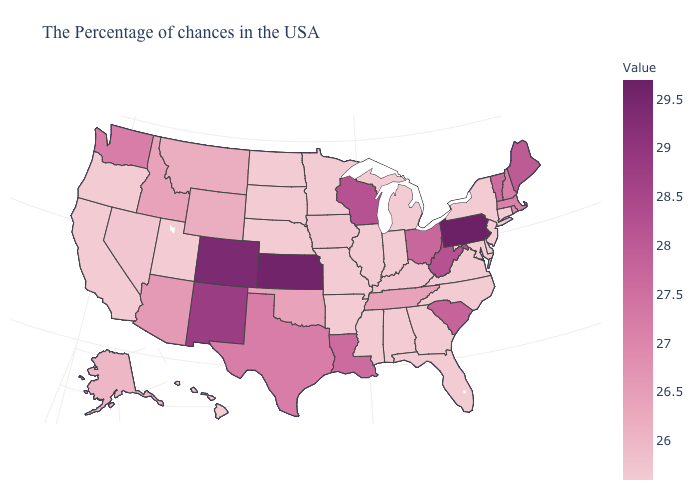Which states hav the highest value in the West?
Concise answer only. Colorado. Does Georgia have the lowest value in the USA?
Write a very short answer. Yes. Which states have the lowest value in the USA?
Keep it brief. Connecticut, New York, New Jersey, Delaware, Maryland, Virginia, North Carolina, Florida, Georgia, Michigan, Indiana, Alabama, Illinois, Mississippi, Missouri, Arkansas, Minnesota, Nebraska, South Dakota, North Dakota, Utah, California, Oregon, Hawaii. Does Maryland have the lowest value in the USA?
Write a very short answer. Yes. Is the legend a continuous bar?
Be succinct. Yes. 